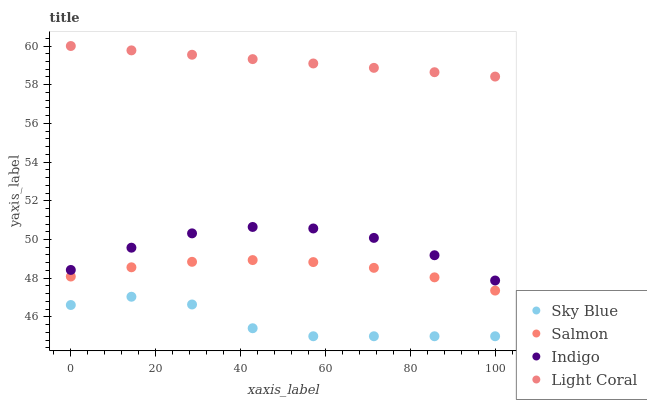Does Sky Blue have the minimum area under the curve?
Answer yes or no. Yes. Does Light Coral have the maximum area under the curve?
Answer yes or no. Yes. Does Salmon have the minimum area under the curve?
Answer yes or no. No. Does Salmon have the maximum area under the curve?
Answer yes or no. No. Is Light Coral the smoothest?
Answer yes or no. Yes. Is Sky Blue the roughest?
Answer yes or no. Yes. Is Salmon the smoothest?
Answer yes or no. No. Is Salmon the roughest?
Answer yes or no. No. Does Sky Blue have the lowest value?
Answer yes or no. Yes. Does Salmon have the lowest value?
Answer yes or no. No. Does Light Coral have the highest value?
Answer yes or no. Yes. Does Salmon have the highest value?
Answer yes or no. No. Is Indigo less than Light Coral?
Answer yes or no. Yes. Is Light Coral greater than Sky Blue?
Answer yes or no. Yes. Does Indigo intersect Light Coral?
Answer yes or no. No. 